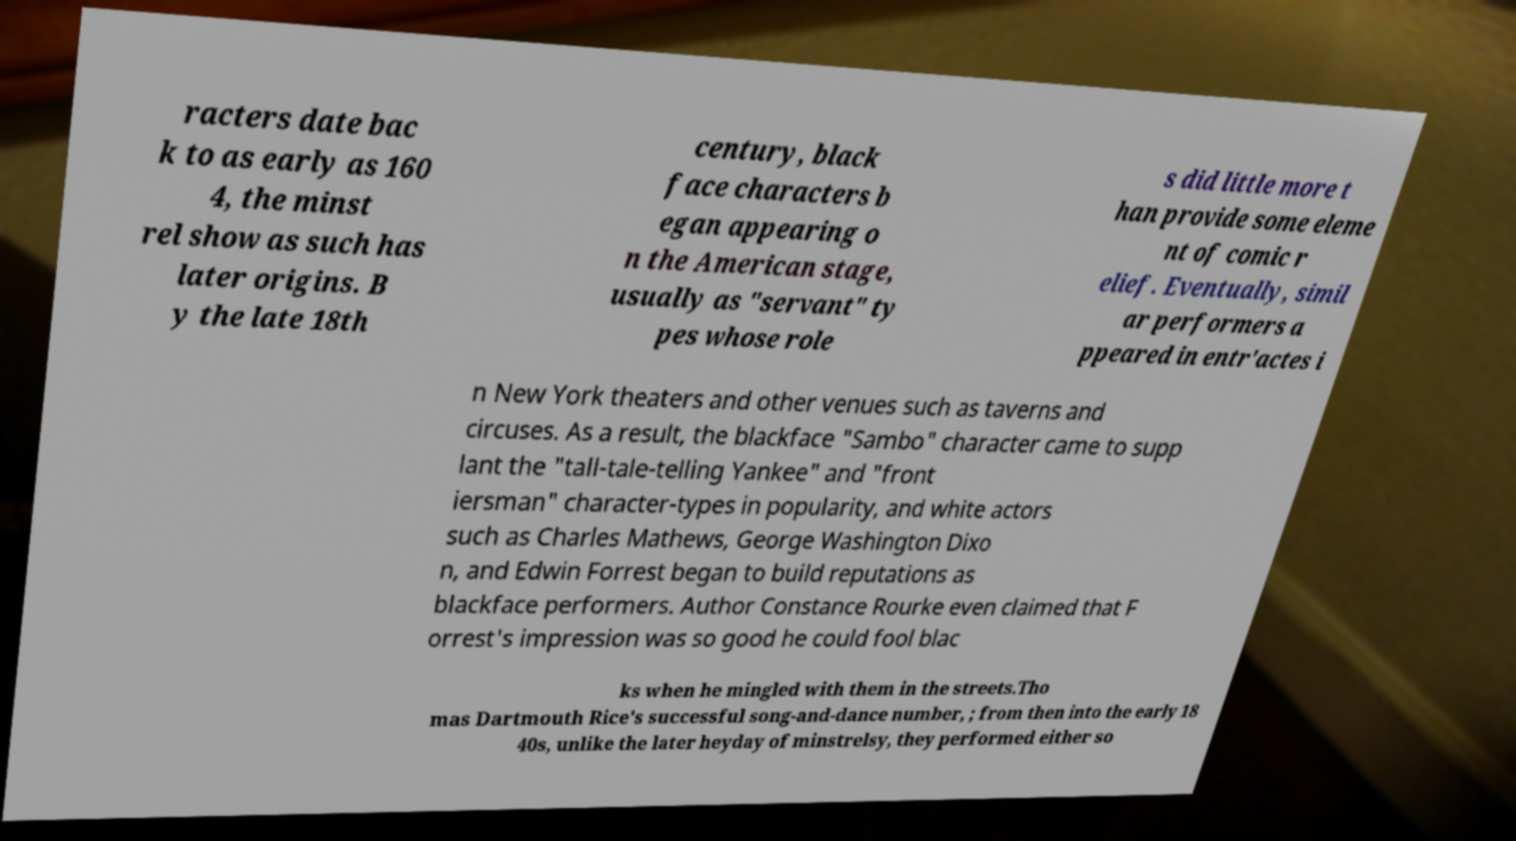I need the written content from this picture converted into text. Can you do that? racters date bac k to as early as 160 4, the minst rel show as such has later origins. B y the late 18th century, black face characters b egan appearing o n the American stage, usually as "servant" ty pes whose role s did little more t han provide some eleme nt of comic r elief. Eventually, simil ar performers a ppeared in entr'actes i n New York theaters and other venues such as taverns and circuses. As a result, the blackface "Sambo" character came to supp lant the "tall-tale-telling Yankee" and "front iersman" character-types in popularity, and white actors such as Charles Mathews, George Washington Dixo n, and Edwin Forrest began to build reputations as blackface performers. Author Constance Rourke even claimed that F orrest's impression was so good he could fool blac ks when he mingled with them in the streets.Tho mas Dartmouth Rice's successful song-and-dance number, ; from then into the early 18 40s, unlike the later heyday of minstrelsy, they performed either so 